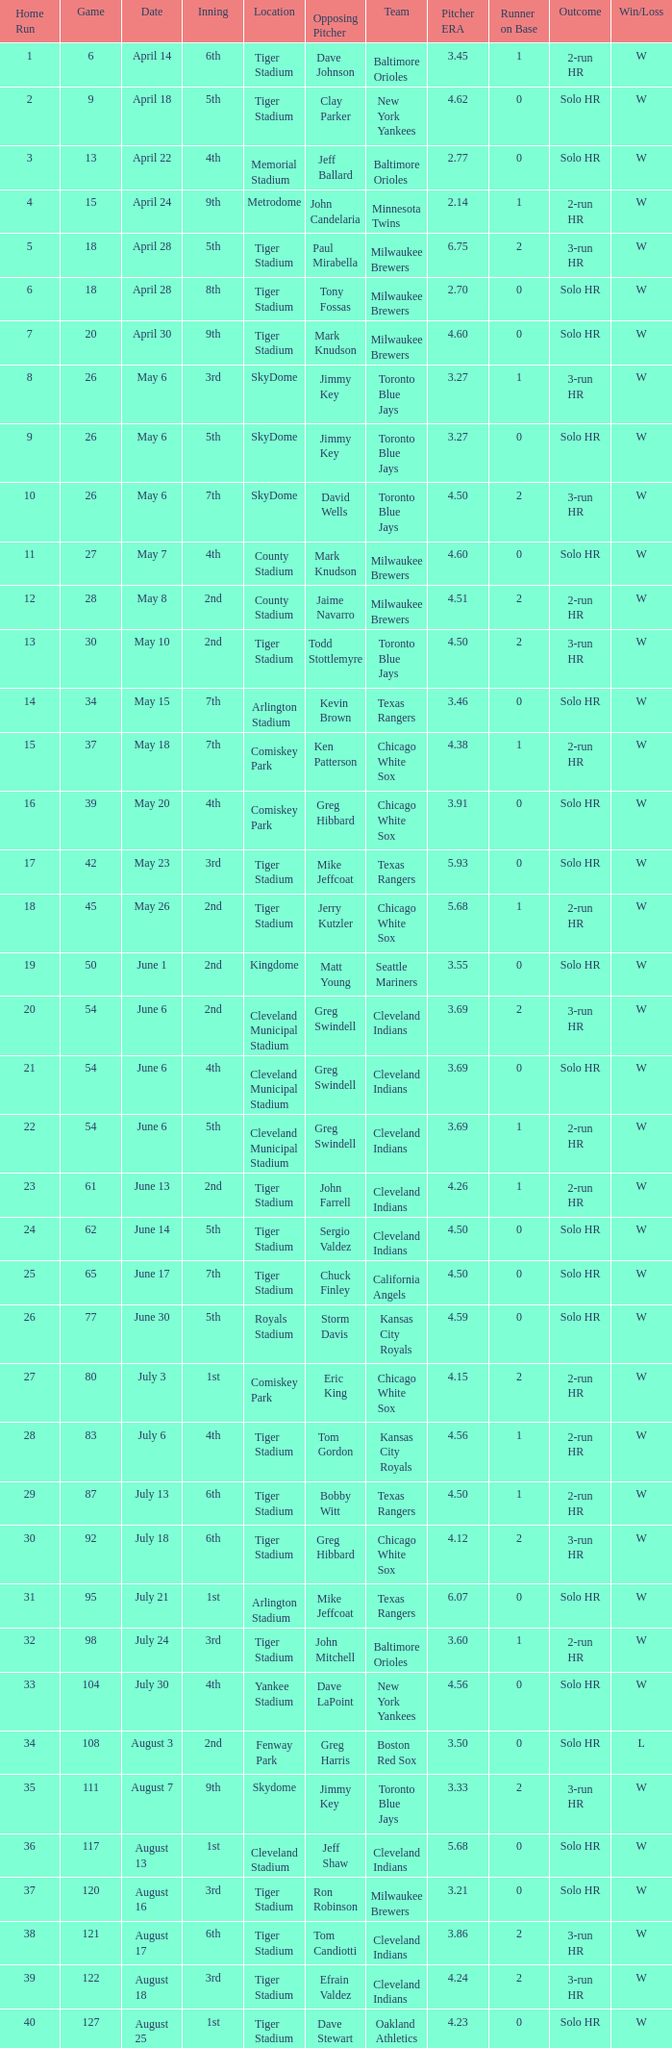On June 17 in Tiger stadium, what was the average home run? 25.0. 